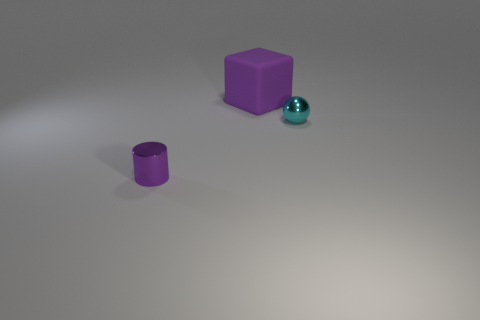What number of small metallic balls are the same color as the big matte thing?
Give a very brief answer. 0. What shape is the object that is in front of the big object and left of the tiny sphere?
Provide a short and direct response. Cylinder. There is a thing that is in front of the large matte block and behind the purple metal thing; what color is it?
Your response must be concise. Cyan. Are there more big cubes that are in front of the shiny sphere than tiny purple metallic cylinders that are to the right of the large purple cube?
Provide a succinct answer. No. What is the color of the object that is behind the cyan metallic thing?
Your response must be concise. Purple. There is a shiny object that is right of the small purple shiny thing; does it have the same shape as the purple thing on the right side of the purple cylinder?
Your answer should be very brief. No. Are there any yellow rubber cylinders that have the same size as the purple matte object?
Your response must be concise. No. What material is the object that is left of the rubber thing?
Make the answer very short. Metal. Does the tiny thing that is to the left of the small cyan ball have the same material as the big thing?
Give a very brief answer. No. Are there any cyan metal things?
Your answer should be compact. Yes. 